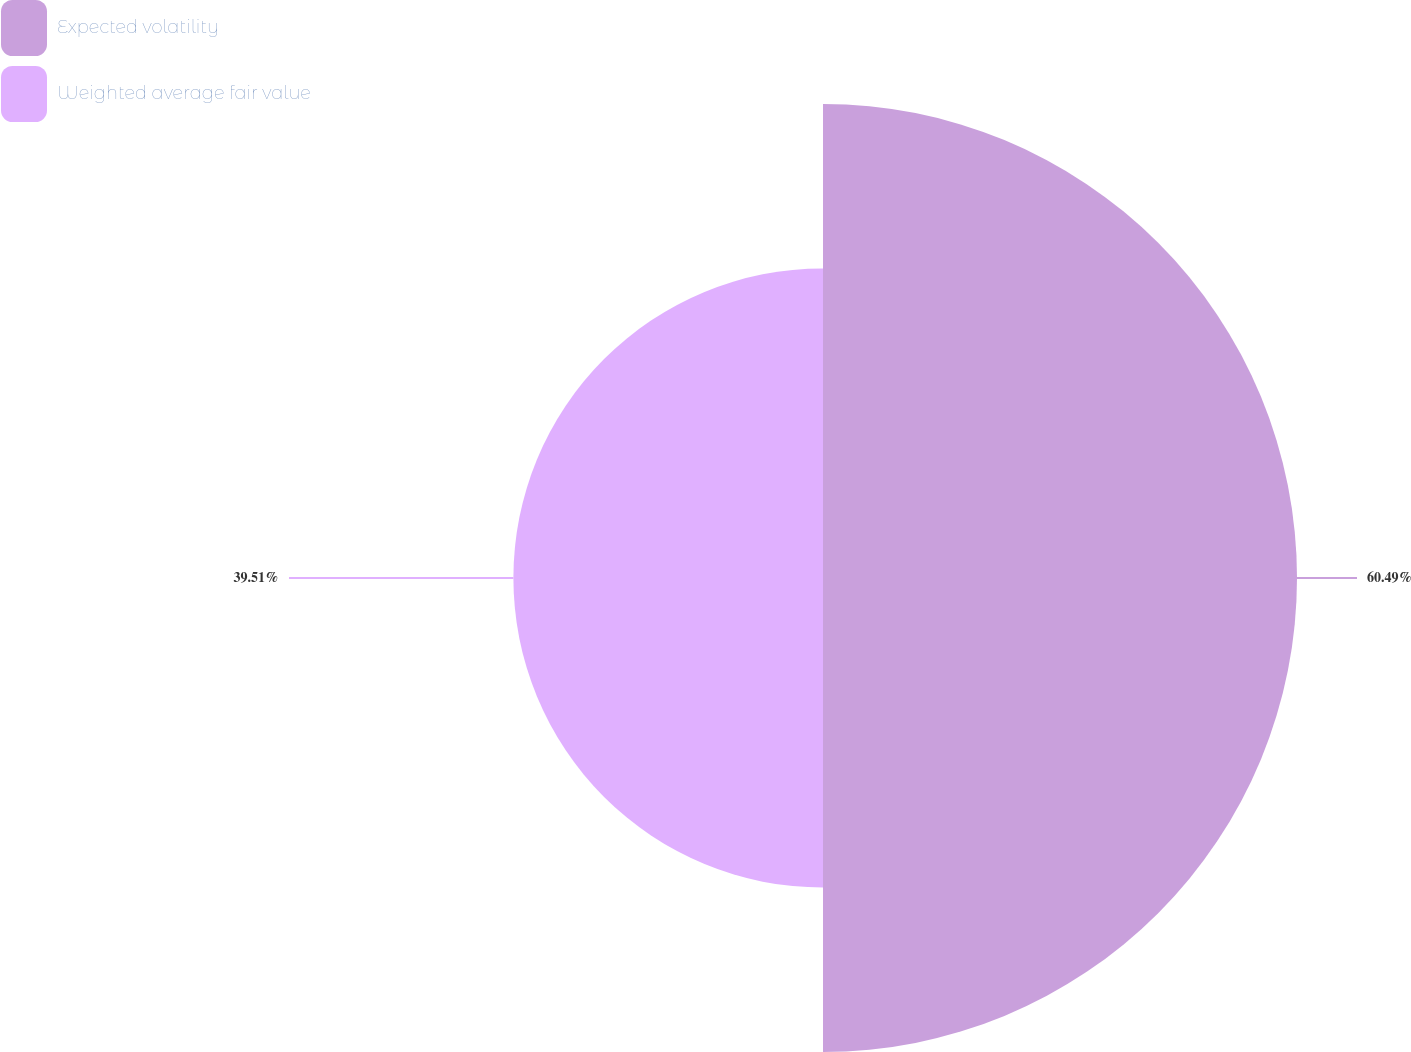Convert chart. <chart><loc_0><loc_0><loc_500><loc_500><pie_chart><fcel>Expected volatility<fcel>Weighted average fair value<nl><fcel>60.49%<fcel>39.51%<nl></chart> 